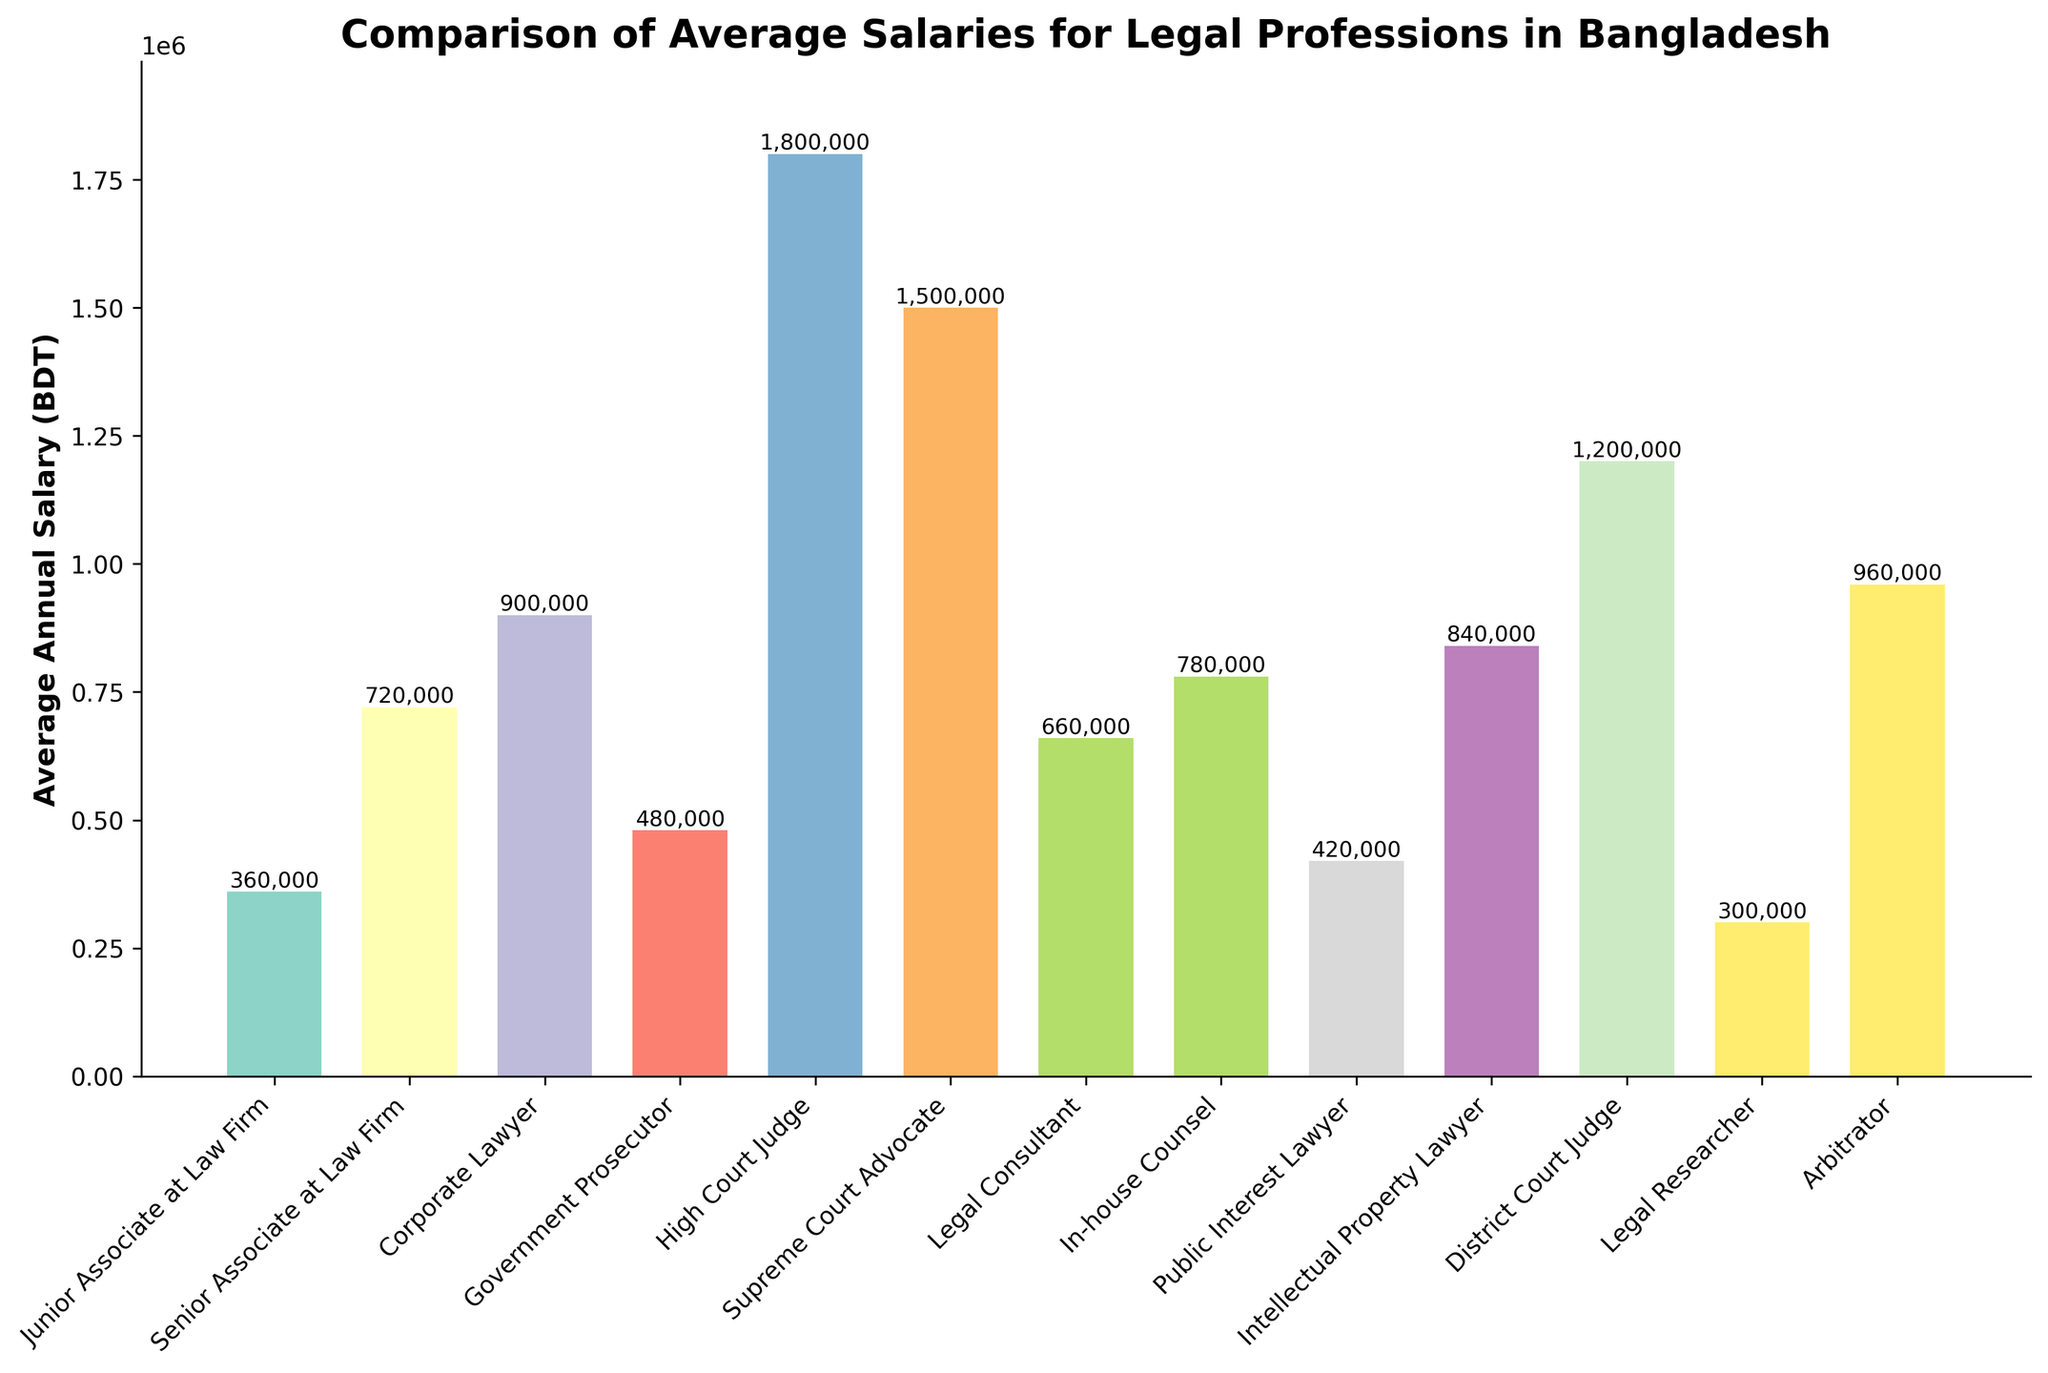What's the average salary of a Legal Consultant and an Arbitrator combined? First, we sum the salaries of a Legal Consultant (660,000 BDT) and an Arbitrator (960,000 BDT), giving a total of 1,620,000 BDT. Then, we divide by 2 to find the average: 1,620,000 / 2 = 810,000 BDT.
Answer: 810,000 BDT Which legal profession has the highest average annual salary? By examining the heights of the bars, the High Court Judge has the highest bar, corresponding to the highest average salary of 1,800,000 BDT.
Answer: High Court Judge Which profession earns more, an In-house Counsel or a Corporate Lawyer and by how much? The average salary for an In-house Counsel is 780,000 BDT while for a Corporate Lawyer it is 900,000 BDT. To find the difference, we subtract 780,000 from 900,000, which is 120,000 BDT.
Answer: Corporate Lawyer, 120,000 BDT What’s the combined salary of Junior Associate at Law Firm, Senior Associate at Law Firm, and Supreme Court Advocate? Add the salaries for a Junior Associate at Law Firm (360,000 BDT), a Senior Associate at Law Firm (720,000 BDT), and a Supreme Court Advocate (1,500,000 BDT): 360,000 + 720,000 + 1,500,000 = 2,580,000 BDT.
Answer: 2,580,000 BDT Which legal profession has the lowest average annual salary? By looking at the shortest bar on the chart, the profession with the lowest average salary is the Junior Associate at Law Firm with 360,000 BDT.
Answer: Junior Associate at Law Firm How does the salary of a High Court Judge compare to a District Court Judge? The average salary of a High Court Judge is 1,800,000 BDT, while that of a District Court Judge is 1,200,000 BDT. The High Court Judge earns 600,000 BDT more.
Answer: High Court Judge earns 600,000 BDT more Is the average salary for a Government Prosecutor higher or lower than that of a Legal Consultant and by how much? The average salary of a Government Prosecutor is 480,000 BDT, while that of a Legal Consultant is 660,000 BDT. The difference is 660,000 - 480,000 = 180,000 BDT.
Answer: Lower by 180,000 BDT What is the total annual salary of all listed legal professions combined? Add all the salaries: 360,000 + 720,000 + 900,000 + 480,000 + 1,800,000 + 1,500,000 + 660,000 + 780,000 + 420,000 + 840,000 + 1,200,000 + 300,000 + 960,000 = 10,920,000 BDT.
Answer: 10,920,000 BDT Which profession has a higher average salary: a Senior Associate at Law Firm or an Intellectual Property Lawyer? The average salary of a Senior Associate at Law Firm is 720,000 BDT, and for an Intellectual Property Lawyer, it is 840,000 BDT. Therefore, the Intellectual Property Lawyer has a higher salary.
Answer: Intellectual Property Lawyer 